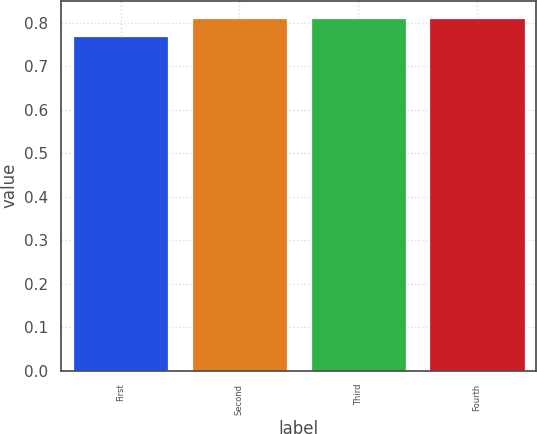<chart> <loc_0><loc_0><loc_500><loc_500><bar_chart><fcel>First<fcel>Second<fcel>Third<fcel>Fourth<nl><fcel>0.77<fcel>0.81<fcel>0.81<fcel>0.81<nl></chart> 